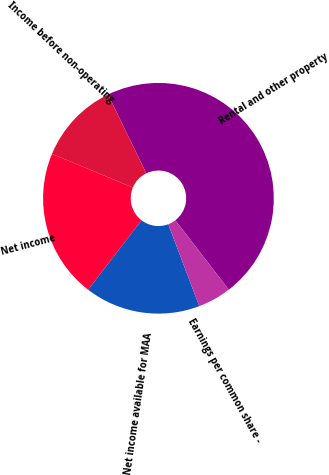<chart> <loc_0><loc_0><loc_500><loc_500><pie_chart><fcel>Rental and other property<fcel>Income before non-operating<fcel>Net income<fcel>Net income available for MAA<fcel>Earnings per common share -<nl><fcel>46.76%<fcel>11.51%<fcel>20.86%<fcel>16.19%<fcel>4.68%<nl></chart> 